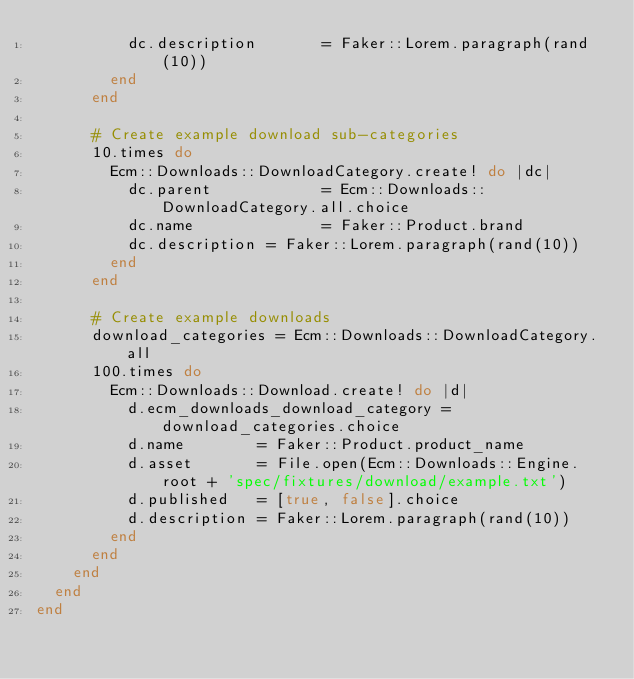Convert code to text. <code><loc_0><loc_0><loc_500><loc_500><_Ruby_>          dc.description       = Faker::Lorem.paragraph(rand(10))
        end
      end

      # Create example download sub-categories
      10.times do
        Ecm::Downloads::DownloadCategory.create! do |dc|
          dc.parent            = Ecm::Downloads::DownloadCategory.all.choice
          dc.name              = Faker::Product.brand
          dc.description = Faker::Lorem.paragraph(rand(10))
        end
      end

      # Create example downloads
      download_categories = Ecm::Downloads::DownloadCategory.all
      100.times do
        Ecm::Downloads::Download.create! do |d|
          d.ecm_downloads_download_category = download_categories.choice
          d.name        = Faker::Product.product_name
          d.asset       = File.open(Ecm::Downloads::Engine.root + 'spec/fixtures/download/example.txt')
          d.published   = [true, false].choice
          d.description = Faker::Lorem.paragraph(rand(10))
        end
      end
    end
  end
end
</code> 